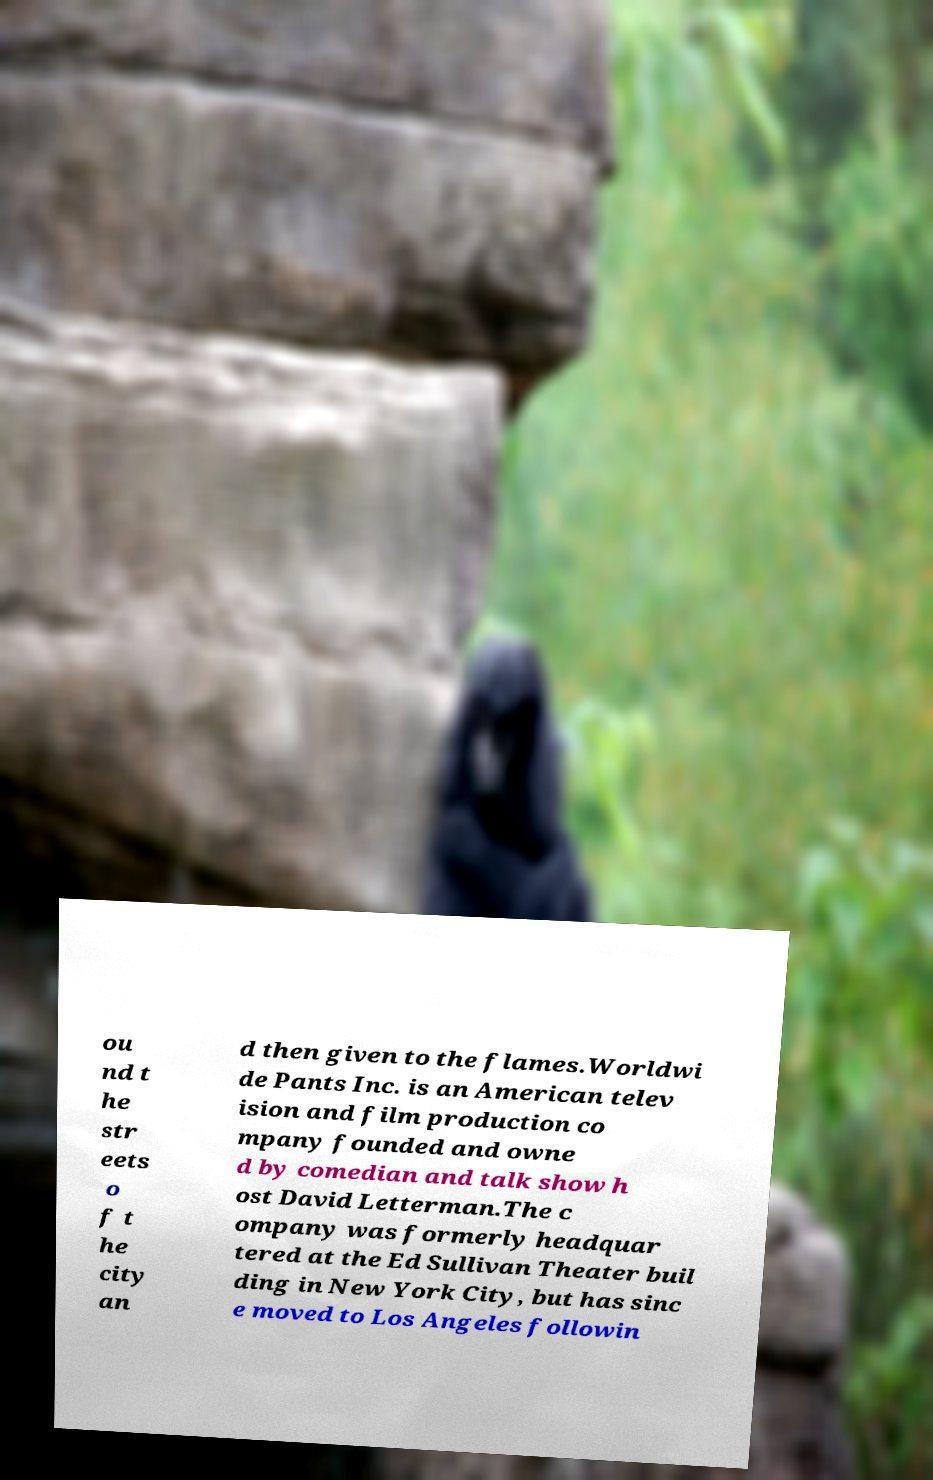Can you accurately transcribe the text from the provided image for me? ou nd t he str eets o f t he city an d then given to the flames.Worldwi de Pants Inc. is an American telev ision and film production co mpany founded and owne d by comedian and talk show h ost David Letterman.The c ompany was formerly headquar tered at the Ed Sullivan Theater buil ding in New York City, but has sinc e moved to Los Angeles followin 